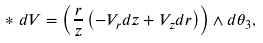<formula> <loc_0><loc_0><loc_500><loc_500>* d V = \left ( \frac { r } { z } \left ( - V _ { r } d z + V _ { z } d r \right ) \right ) \wedge d \theta _ { 3 } ,</formula> 